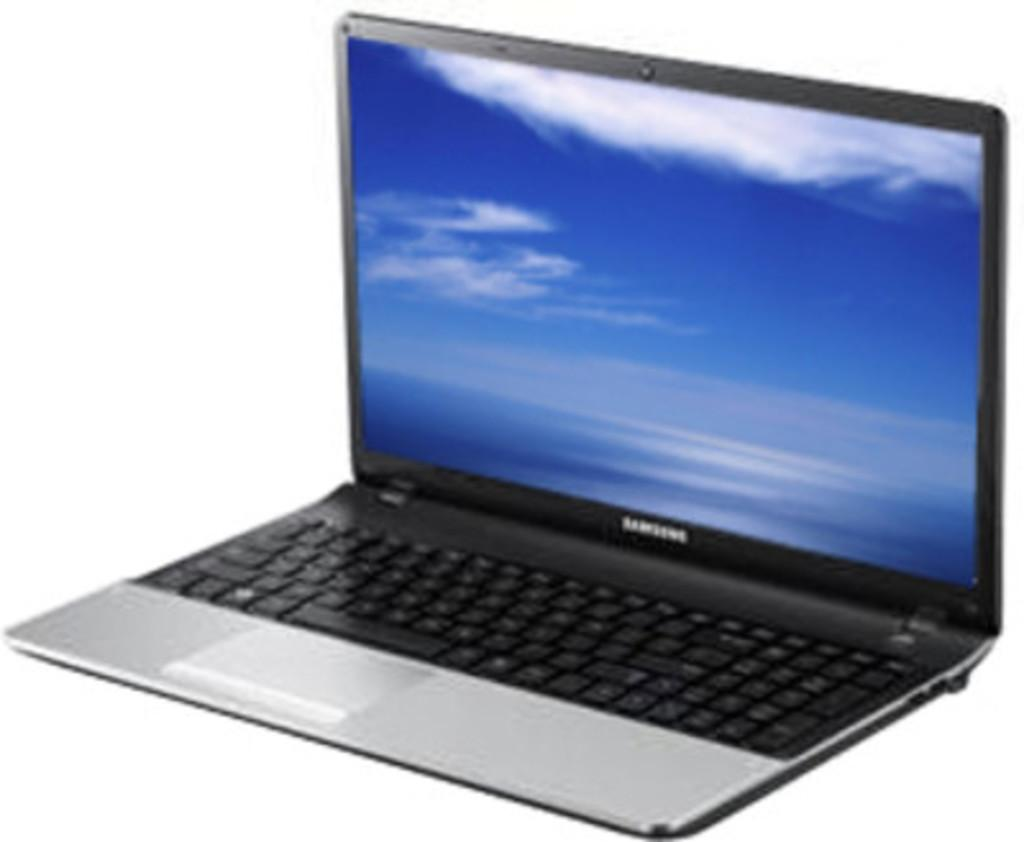<image>
Give a short and clear explanation of the subsequent image. a silver sleek Samsung lap top computer with clouds on the screen 